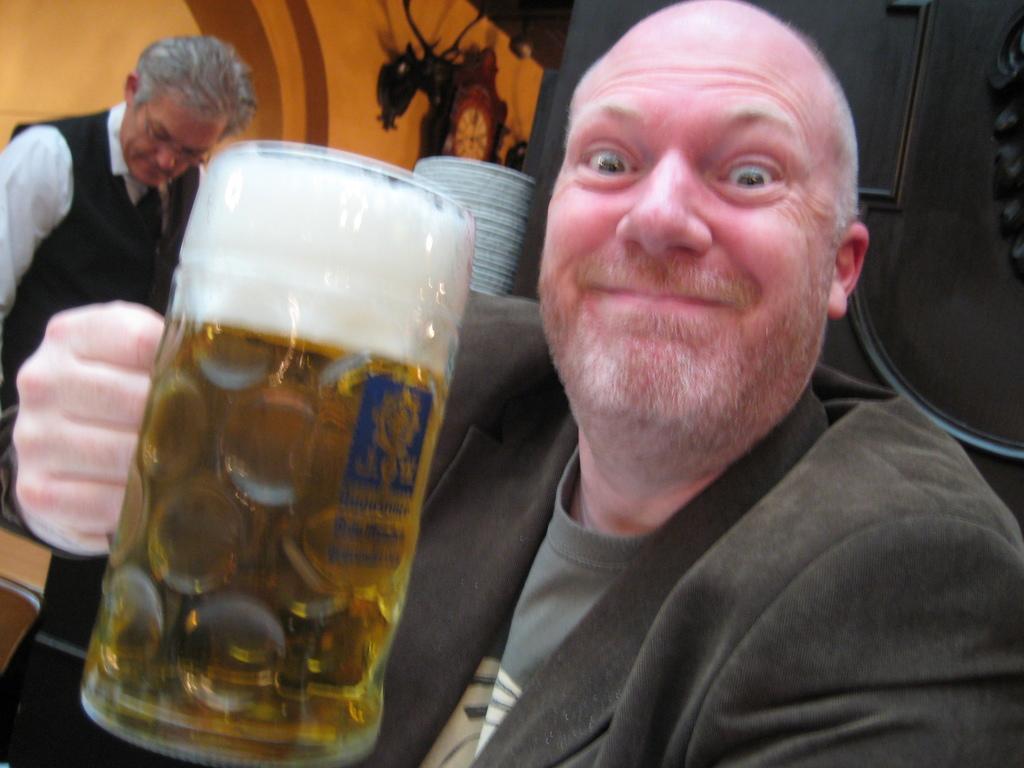Can you describe this image briefly? In this image there is a person holding a glass of beer in his hand, behind the person there is a bartender, in front of him there are plates, in the background of the image there is the wall clock. 